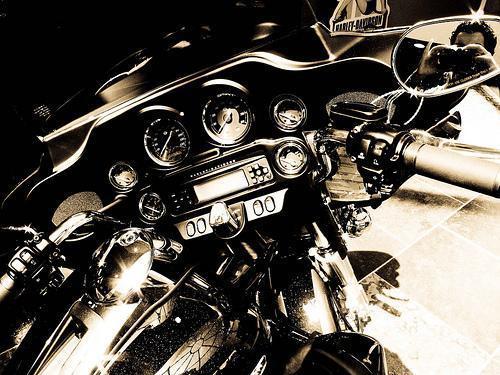How many people are in this picture?
Give a very brief answer. 1. How many bikes are pictured?
Give a very brief answer. 1. How many handles are pictured?
Give a very brief answer. 2. 